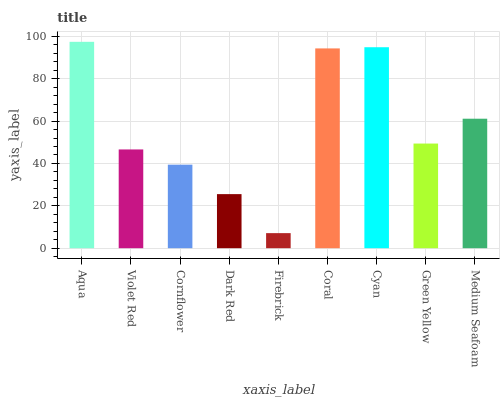Is Firebrick the minimum?
Answer yes or no. Yes. Is Aqua the maximum?
Answer yes or no. Yes. Is Violet Red the minimum?
Answer yes or no. No. Is Violet Red the maximum?
Answer yes or no. No. Is Aqua greater than Violet Red?
Answer yes or no. Yes. Is Violet Red less than Aqua?
Answer yes or no. Yes. Is Violet Red greater than Aqua?
Answer yes or no. No. Is Aqua less than Violet Red?
Answer yes or no. No. Is Green Yellow the high median?
Answer yes or no. Yes. Is Green Yellow the low median?
Answer yes or no. Yes. Is Medium Seafoam the high median?
Answer yes or no. No. Is Medium Seafoam the low median?
Answer yes or no. No. 